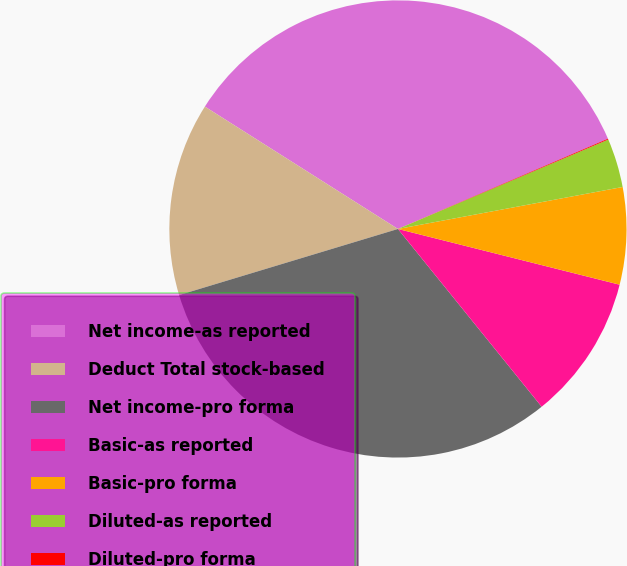Convert chart. <chart><loc_0><loc_0><loc_500><loc_500><pie_chart><fcel>Net income-as reported<fcel>Deduct Total stock-based<fcel>Net income-pro forma<fcel>Basic-as reported<fcel>Basic-pro forma<fcel>Diluted-as reported<fcel>Diluted-pro forma<nl><fcel>34.55%<fcel>13.66%<fcel>31.15%<fcel>10.26%<fcel>6.86%<fcel>3.46%<fcel>0.06%<nl></chart> 